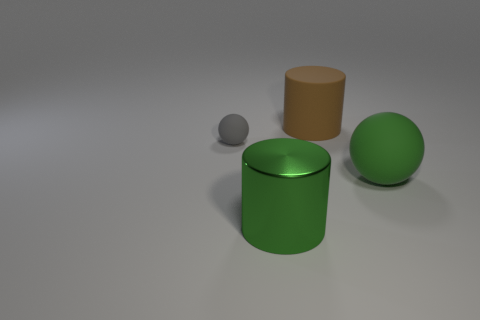What color is the large rubber object that is the same shape as the small thing?
Provide a succinct answer. Green. How many objects are big brown balls or brown matte things?
Keep it short and to the point. 1. What shape is the brown object that is the same material as the small gray sphere?
Offer a very short reply. Cylinder. What number of tiny objects are either brown matte things or purple metallic things?
Provide a succinct answer. 0. How many other objects are there of the same color as the big shiny cylinder?
Give a very brief answer. 1. What number of small rubber balls are behind the green cylinder in front of the large green thing behind the big shiny thing?
Your answer should be very brief. 1. Do the ball that is in front of the gray ball and the big brown matte cylinder have the same size?
Your answer should be compact. Yes. Is the number of green objects behind the big green ball less than the number of rubber objects that are to the left of the green cylinder?
Your response must be concise. Yes. Do the metal thing and the big ball have the same color?
Provide a short and direct response. Yes. Is the number of small objects that are right of the brown cylinder less than the number of red rubber objects?
Your response must be concise. No. 